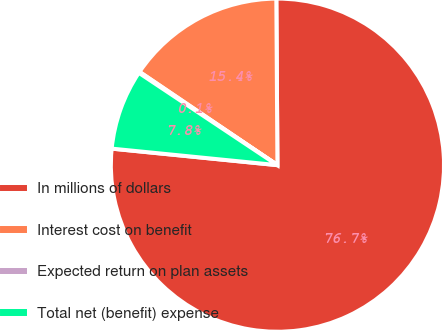Convert chart. <chart><loc_0><loc_0><loc_500><loc_500><pie_chart><fcel>In millions of dollars<fcel>Interest cost on benefit<fcel>Expected return on plan assets<fcel>Total net (benefit) expense<nl><fcel>76.69%<fcel>15.43%<fcel>0.11%<fcel>7.77%<nl></chart> 